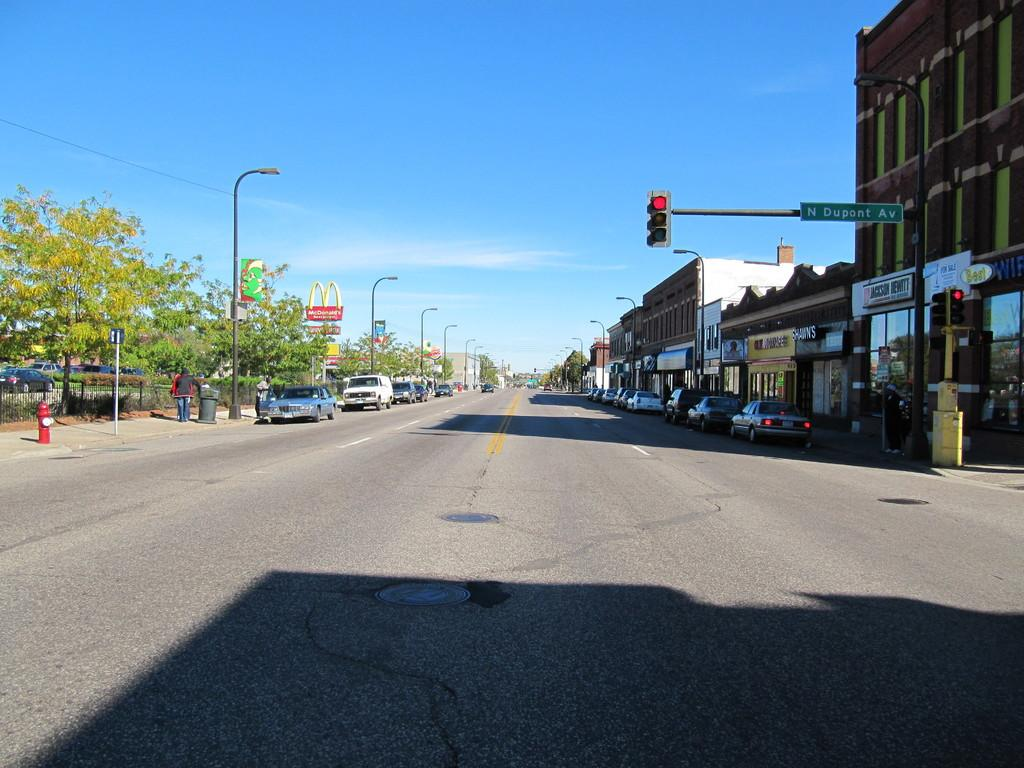What can be seen parked on the road in the image? Vehicles are parked on the road in the image. What safety feature is present in the image? There is a hydrant in the image. What type of infrastructure is present in the image? There are lights on poles and traffic signals on poles in the image. What type of structures are visible in the image? There are buildings visible in the image. What type of vegetation is present in the image? Trees are present in the image. What part of the natural environment is visible in the image? The sky is visible in the image. What color is the shirt worn by the tree in the image? There are no trees wearing shirts in the image; trees are plants and do not wear clothing. What time of day is depicted in the image? The time of day is not mentioned in the provided facts, so it cannot be determined from the image. 